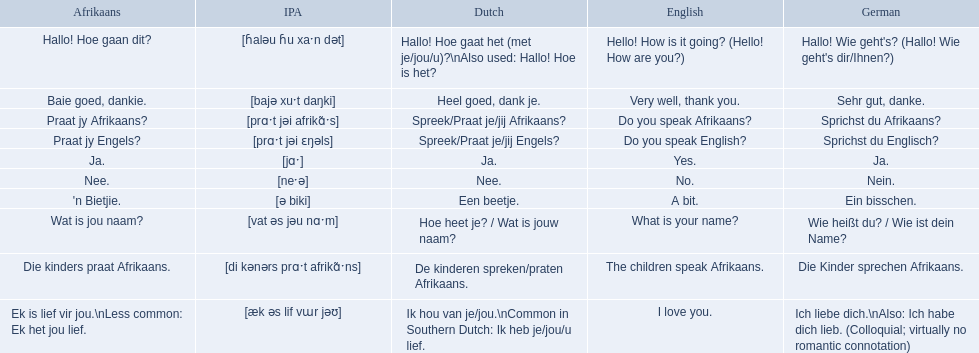What's the afrikaans translation for greeting someone and asking how they are? Hallo! Hoe gaan dit?. How do you respond positively and thank them in afrikaans? Baie goed, dankie. How do you question someone's ability to speak afrikaans, in afrikaans? Praat jy Afrikaans?. 